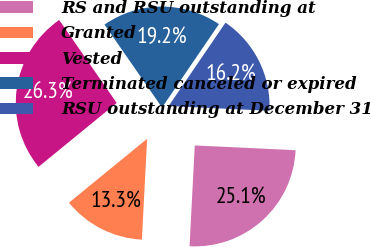Convert chart. <chart><loc_0><loc_0><loc_500><loc_500><pie_chart><fcel>RS and RSU outstanding at<fcel>Granted<fcel>Vested<fcel>Terminated canceled or expired<fcel>RSU outstanding at December 31<nl><fcel>25.07%<fcel>13.27%<fcel>26.25%<fcel>19.17%<fcel>16.22%<nl></chart> 